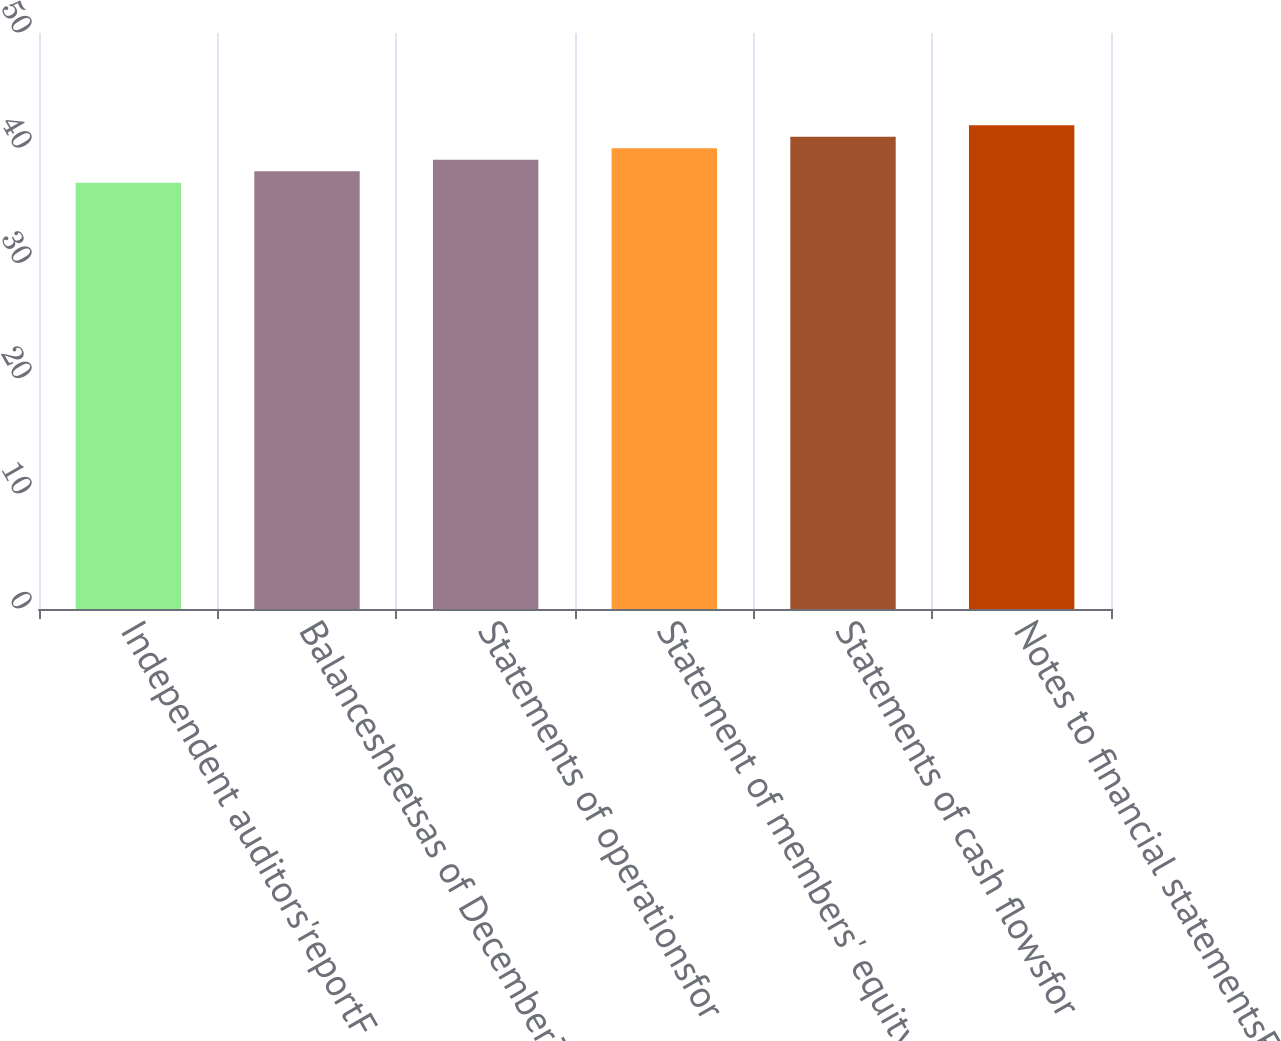Convert chart to OTSL. <chart><loc_0><loc_0><loc_500><loc_500><bar_chart><fcel>Independent auditors'reportF<fcel>Balancesheetsas of December31<fcel>Statements of operationsfor<fcel>Statement of members' equity<fcel>Statements of cash flowsfor<fcel>Notes to financial statementsF<nl><fcel>37<fcel>38<fcel>39<fcel>40<fcel>41<fcel>42<nl></chart> 